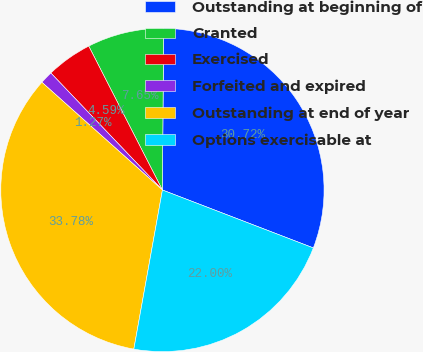<chart> <loc_0><loc_0><loc_500><loc_500><pie_chart><fcel>Outstanding at beginning of<fcel>Granted<fcel>Exercised<fcel>Forfeited and expired<fcel>Outstanding at end of year<fcel>Options exercisable at<nl><fcel>30.72%<fcel>7.65%<fcel>4.59%<fcel>1.27%<fcel>33.78%<fcel>22.0%<nl></chart> 